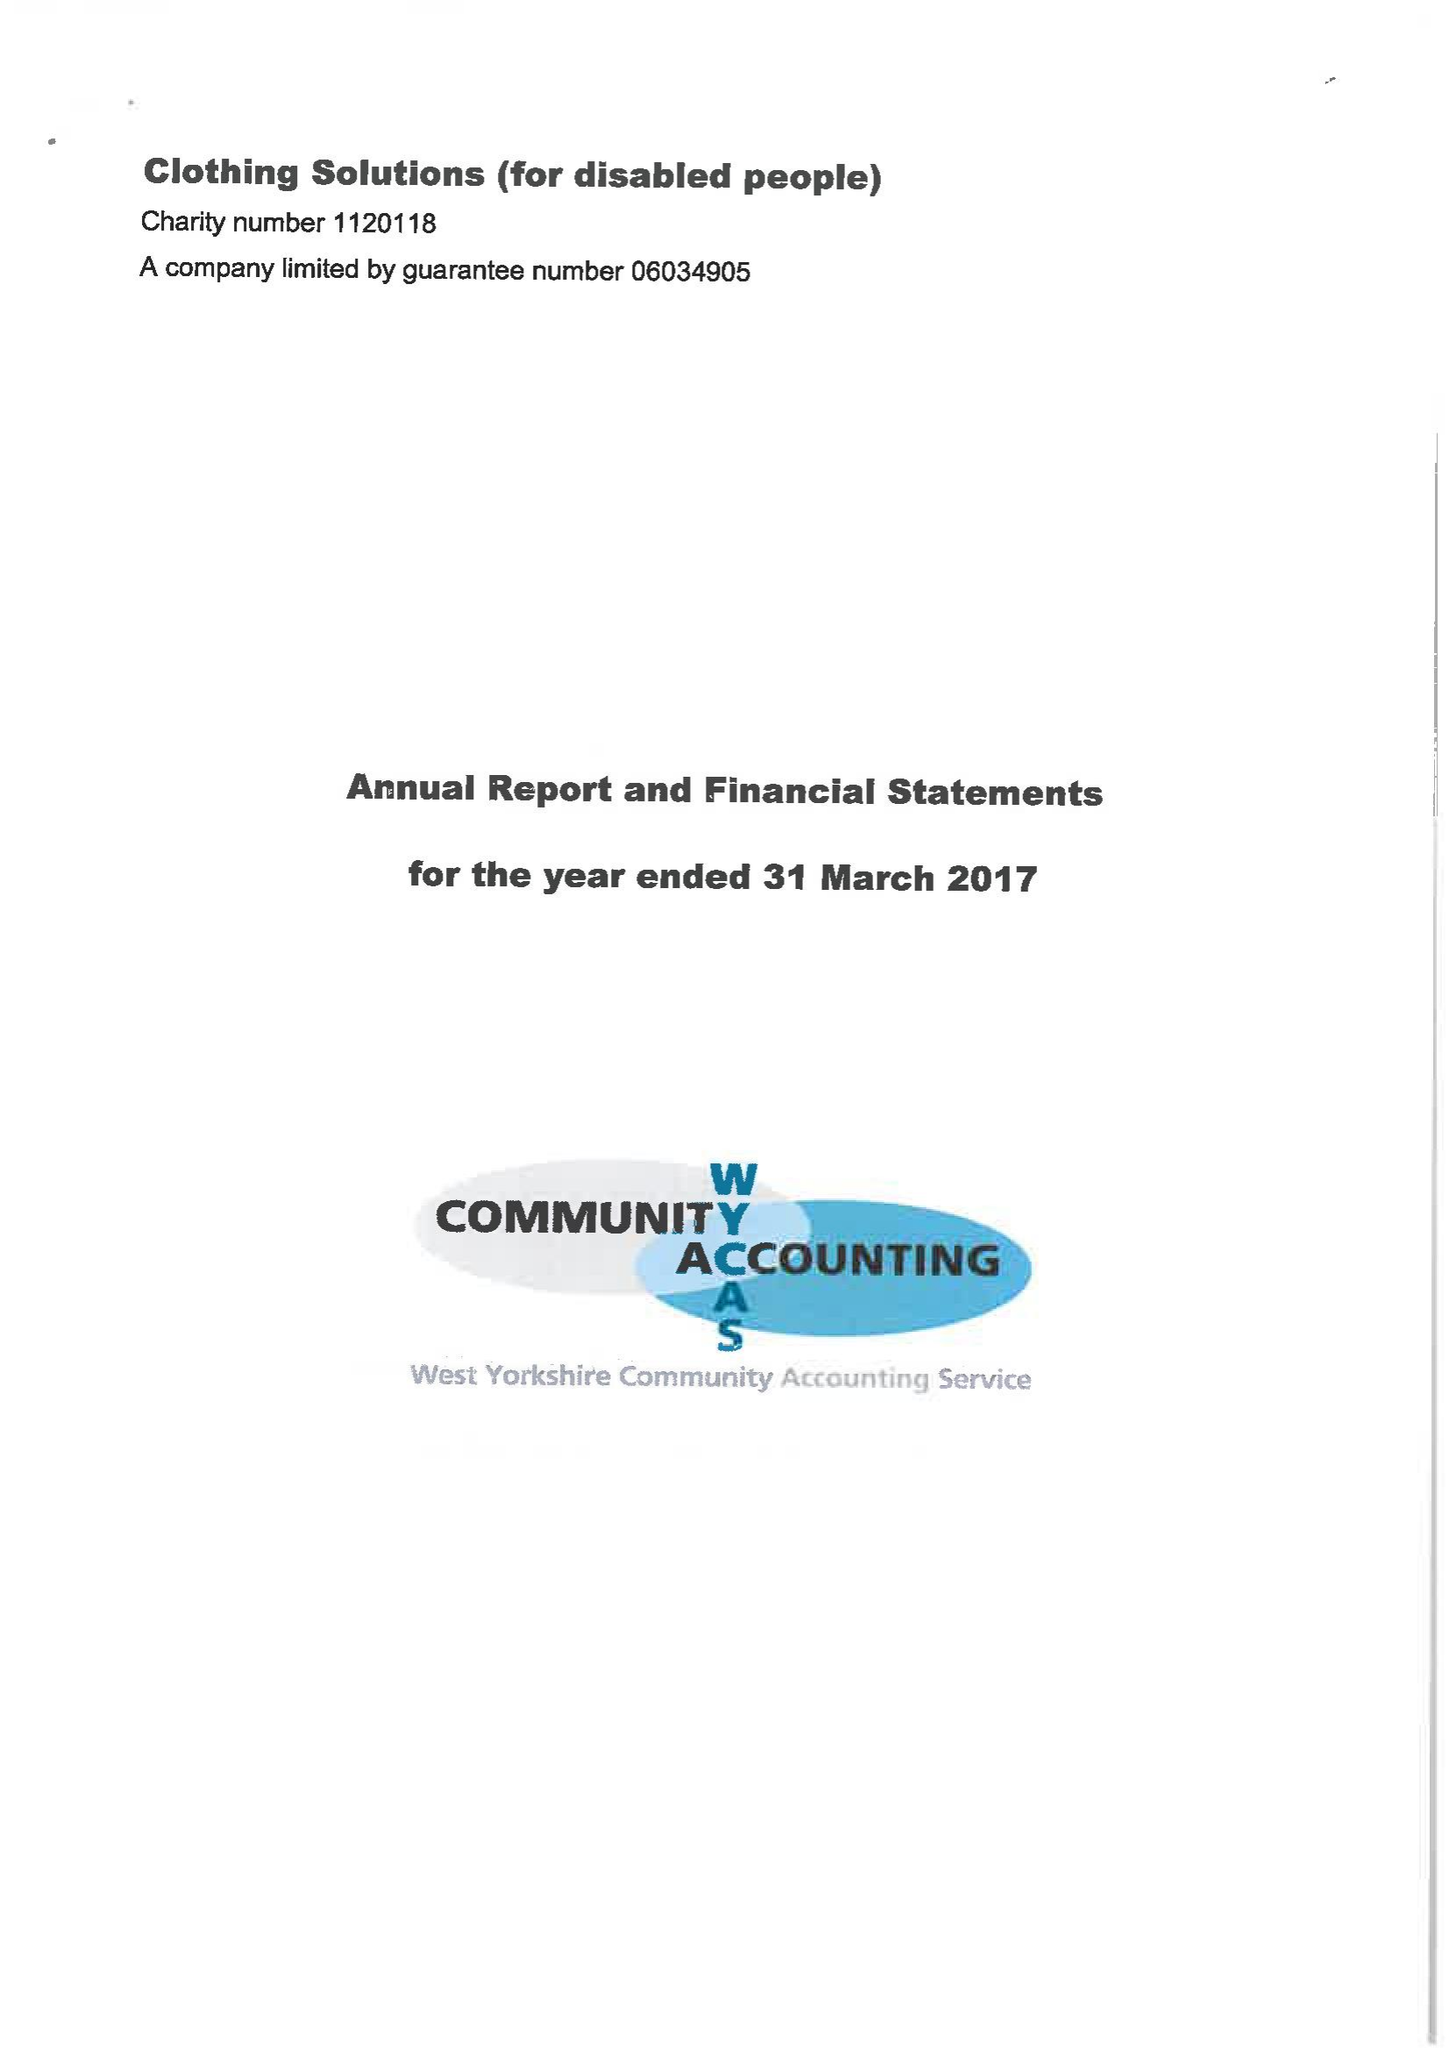What is the value for the address__post_town?
Answer the question using a single word or phrase. None 